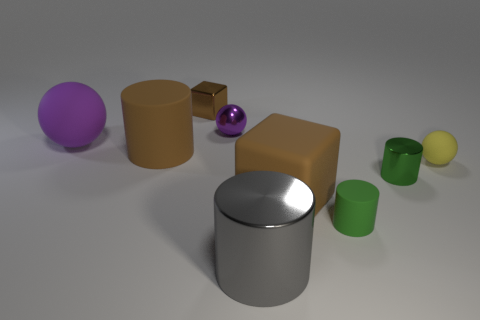Is there anything else that is the same size as the gray thing?
Offer a very short reply. Yes. There is a yellow matte thing that is the same shape as the large purple rubber thing; what is its size?
Offer a terse response. Small. Is the number of big brown rubber things in front of the yellow sphere greater than the number of large cubes that are on the left side of the big purple matte ball?
Offer a terse response. Yes. Does the big purple object have the same material as the sphere in front of the brown cylinder?
Provide a short and direct response. Yes. Is there any other thing that is the same shape as the green matte object?
Give a very brief answer. Yes. What color is the object that is both in front of the small metal sphere and behind the large brown matte cylinder?
Your answer should be very brief. Purple. There is a tiny green thing behind the small green matte object; what shape is it?
Give a very brief answer. Cylinder. There is a ball that is left of the metal sphere behind the brown rubber object right of the small brown block; what size is it?
Make the answer very short. Large. How many small yellow objects are on the right side of the big rubber object that is in front of the yellow rubber ball?
Give a very brief answer. 1. How big is the object that is right of the metal cube and to the left of the big gray metallic cylinder?
Offer a very short reply. Small. 